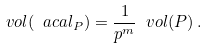<formula> <loc_0><loc_0><loc_500><loc_500>\ v o l ( \ a c a l _ { P } ) = \frac { 1 } { p ^ { m } } \ v o l ( P ) \, .</formula> 